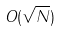<formula> <loc_0><loc_0><loc_500><loc_500>O ( \sqrt { N } )</formula> 